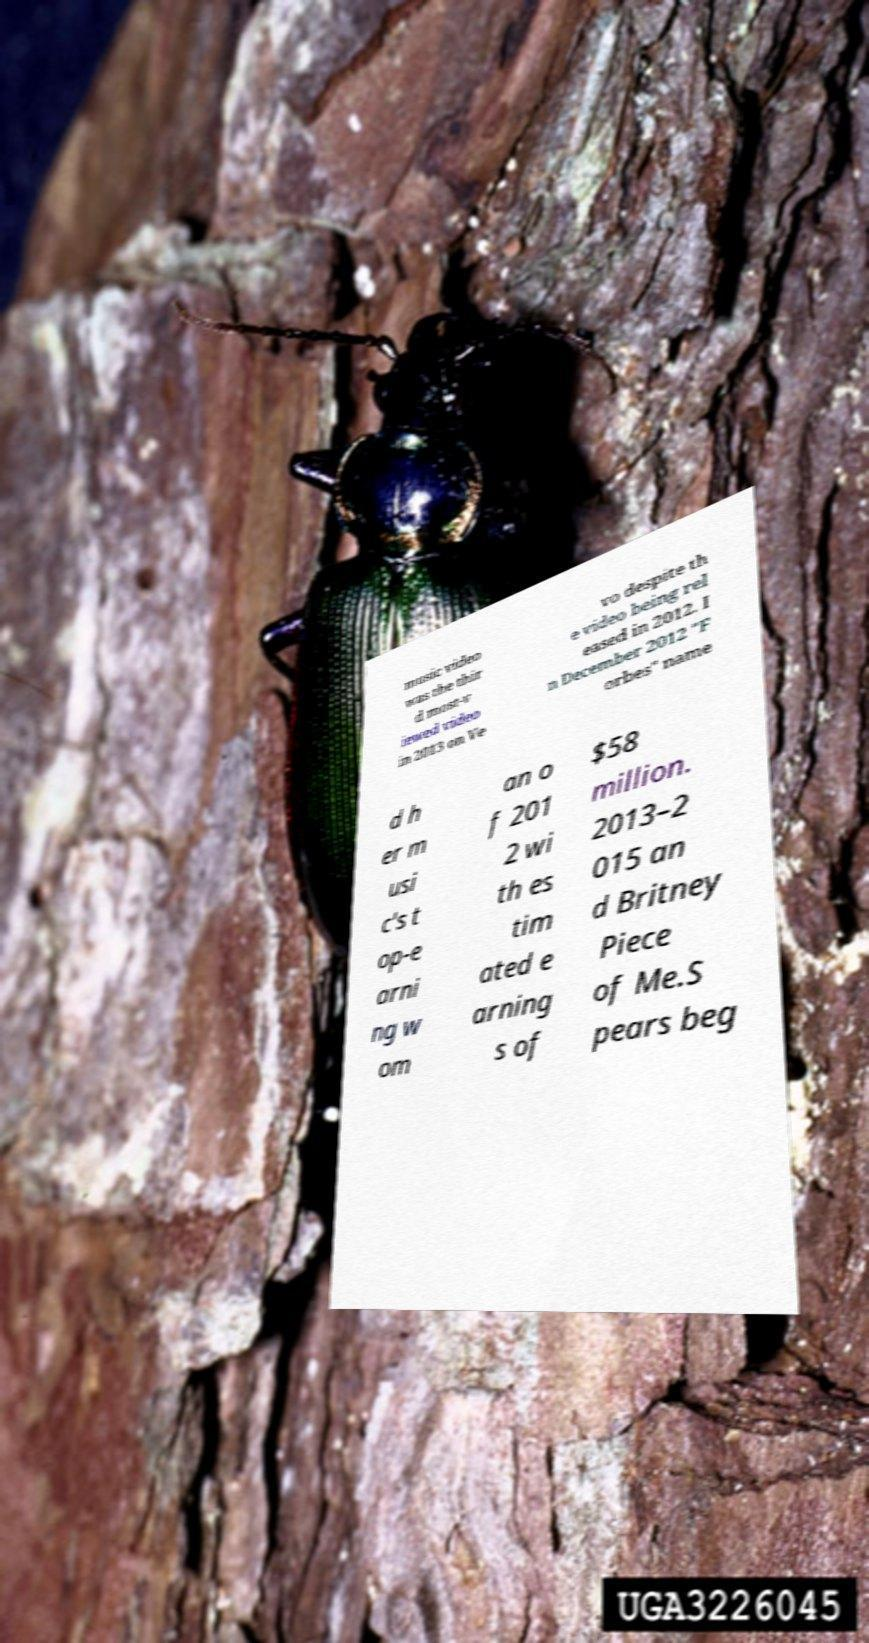Please read and relay the text visible in this image. What does it say? music video was the thir d most-v iewed video in 2013 on Ve vo despite th e video being rel eased in 2012. I n December 2012 "F orbes" name d h er m usi c's t op-e arni ng w om an o f 201 2 wi th es tim ated e arning s of $58 million. 2013–2 015 an d Britney Piece of Me.S pears beg 